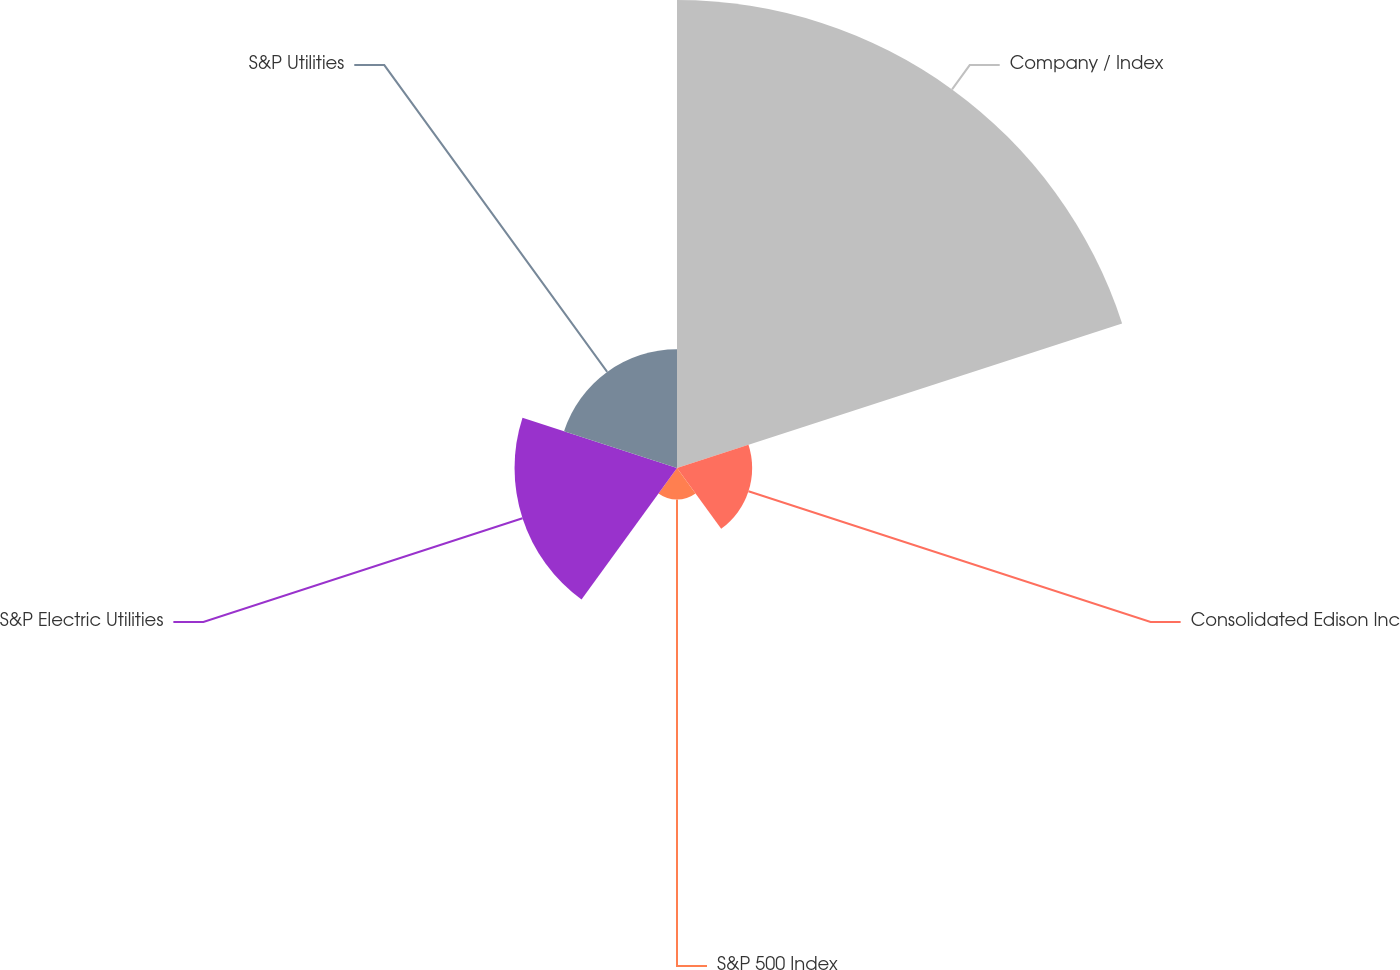Convert chart. <chart><loc_0><loc_0><loc_500><loc_500><pie_chart><fcel>Company / Index<fcel>Consolidated Edison Inc<fcel>S&P 500 Index<fcel>S&P Electric Utilities<fcel>S&P Utilities<nl><fcel>54.68%<fcel>8.78%<fcel>3.68%<fcel>18.98%<fcel>13.88%<nl></chart> 